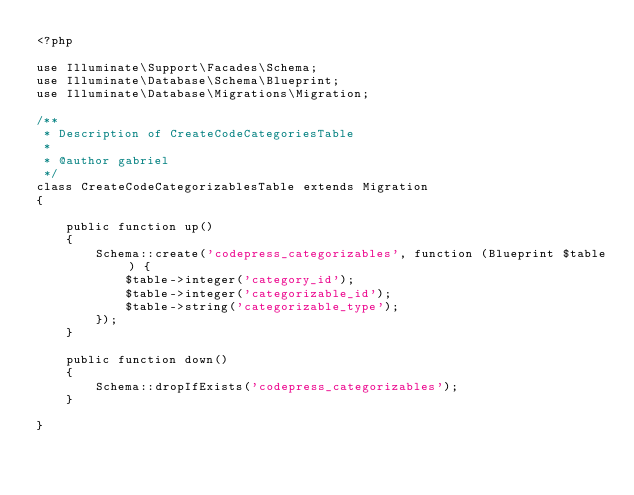Convert code to text. <code><loc_0><loc_0><loc_500><loc_500><_PHP_><?php

use Illuminate\Support\Facades\Schema;
use Illuminate\Database\Schema\Blueprint;
use Illuminate\Database\Migrations\Migration;

/**
 * Description of CreateCodeCategoriesTable
 *
 * @author gabriel
 */
class CreateCodeCategorizablesTable extends Migration
{

    public function up()
    {
        Schema::create('codepress_categorizables', function (Blueprint $table) {
            $table->integer('category_id');
            $table->integer('categorizable_id');
            $table->string('categorizable_type');
        });
    }

    public function down()
    {
        Schema::dropIfExists('codepress_categorizables');
    }

}
</code> 